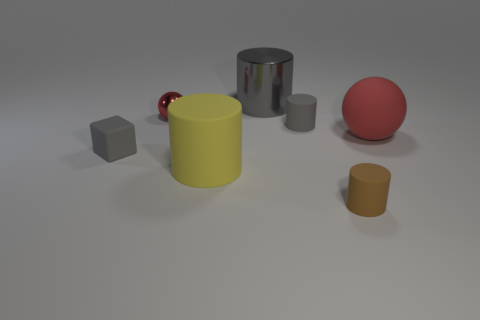Subtract 1 cylinders. How many cylinders are left? 3 Subtract all gray matte cylinders. How many cylinders are left? 3 Subtract all red cylinders. Subtract all brown cubes. How many cylinders are left? 4 Add 3 small cyan metal cylinders. How many objects exist? 10 Subtract all blocks. How many objects are left? 6 Add 4 large gray cylinders. How many large gray cylinders are left? 5 Add 7 small gray things. How many small gray things exist? 9 Subtract 0 brown cubes. How many objects are left? 7 Subtract all tiny rubber blocks. Subtract all big shiny cylinders. How many objects are left? 5 